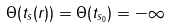Convert formula to latex. <formula><loc_0><loc_0><loc_500><loc_500>\Theta ( t _ { s } ( r ) ) = \Theta ( t _ { s _ { 0 } } ) = - \infty</formula> 